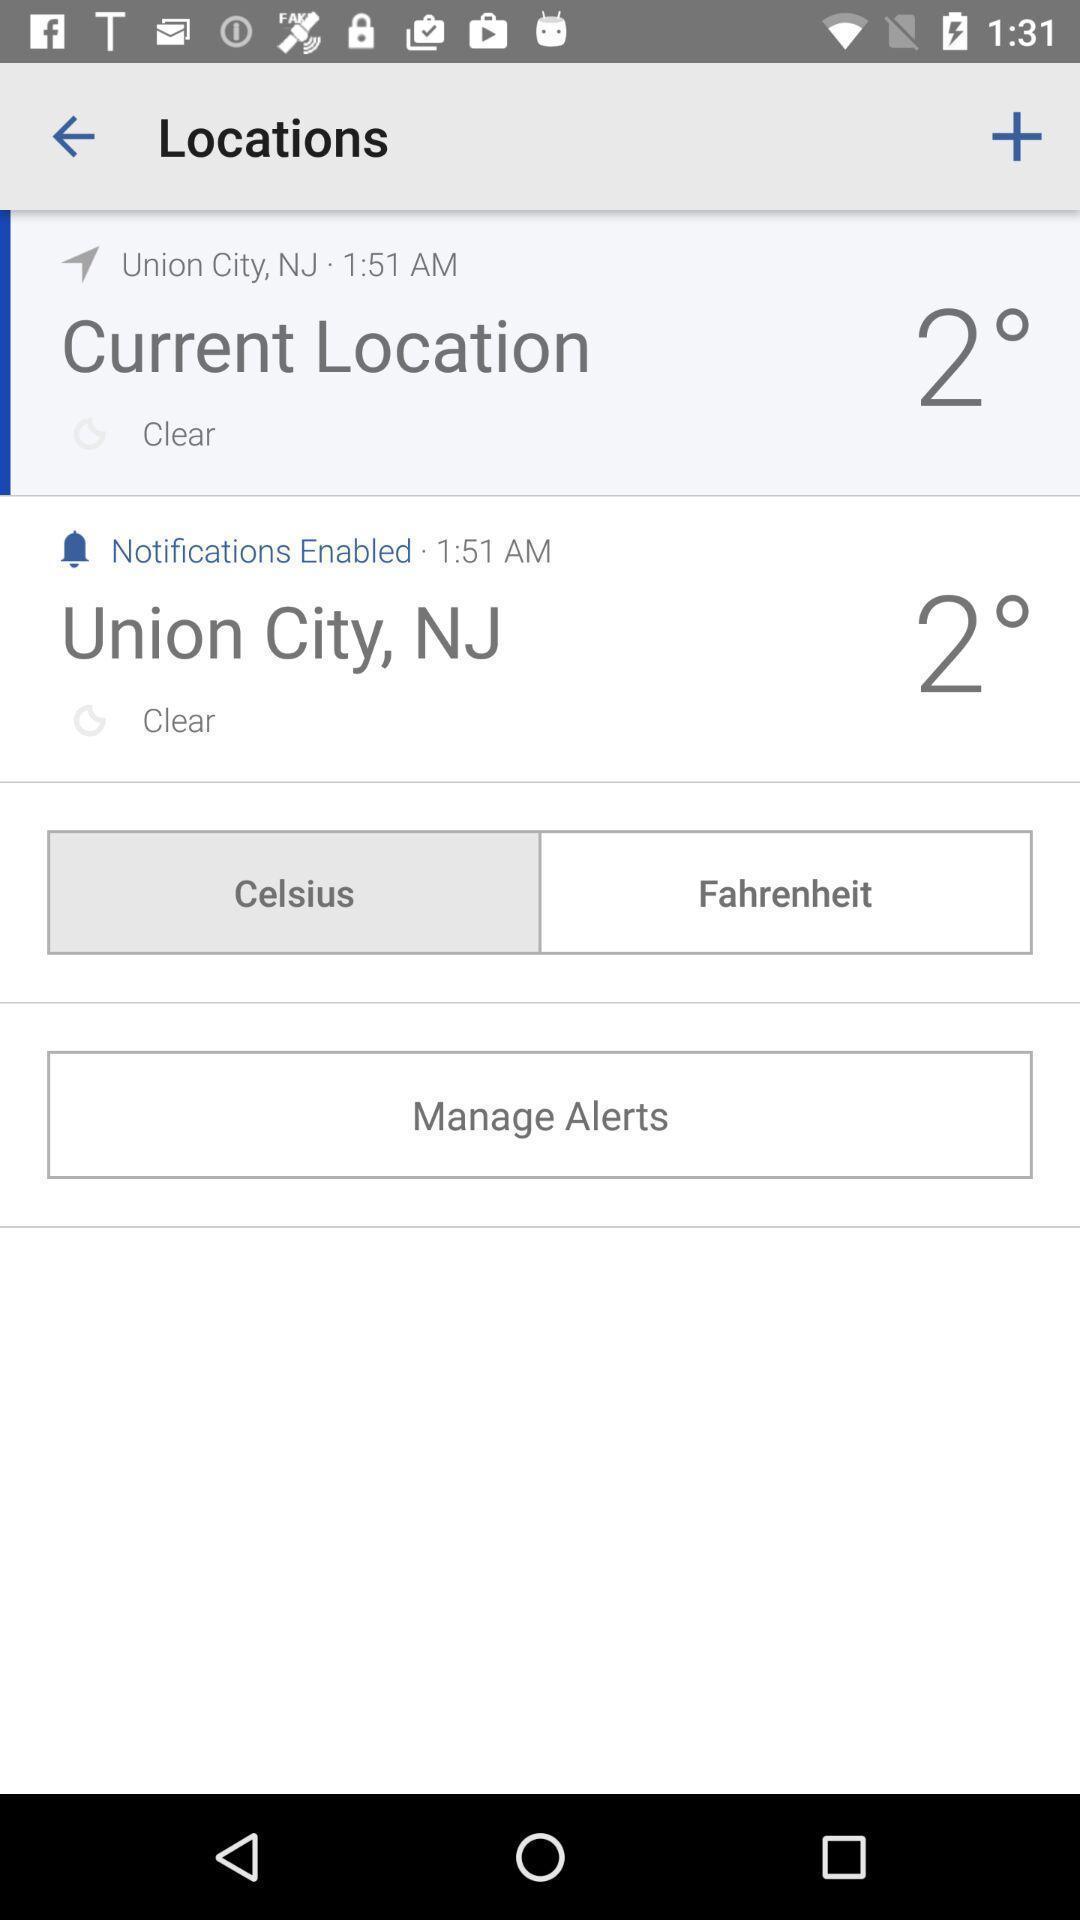Describe the visual elements of this screenshot. Screen displaying the locations with time. 